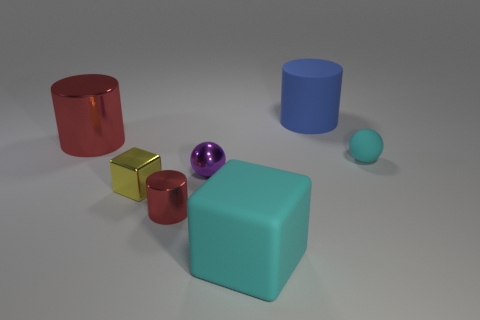Are the materials of the objects indicative of their real-world counterparts? Not precisely. While the objects are suggestive of materials like metal and plastic due to their sheen and colors, they lack specific textures and additional characteristics like weight, which would be essential to fully represent their real-world counterparts. Could you use these objects to explain light reflection? Absolutely. The varying degrees of shine on the objects could be used to demonstrate how different materials reflect light differently, influencing their appearance and visibility. 